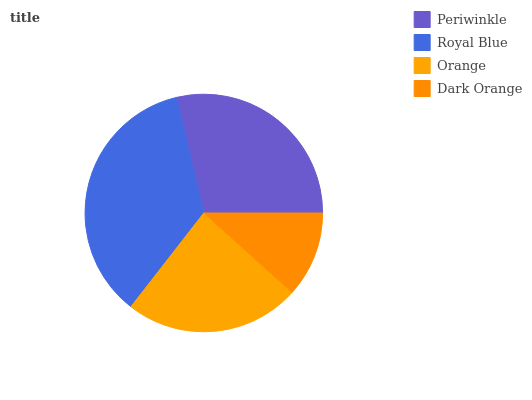Is Dark Orange the minimum?
Answer yes or no. Yes. Is Royal Blue the maximum?
Answer yes or no. Yes. Is Orange the minimum?
Answer yes or no. No. Is Orange the maximum?
Answer yes or no. No. Is Royal Blue greater than Orange?
Answer yes or no. Yes. Is Orange less than Royal Blue?
Answer yes or no. Yes. Is Orange greater than Royal Blue?
Answer yes or no. No. Is Royal Blue less than Orange?
Answer yes or no. No. Is Periwinkle the high median?
Answer yes or no. Yes. Is Orange the low median?
Answer yes or no. Yes. Is Orange the high median?
Answer yes or no. No. Is Periwinkle the low median?
Answer yes or no. No. 